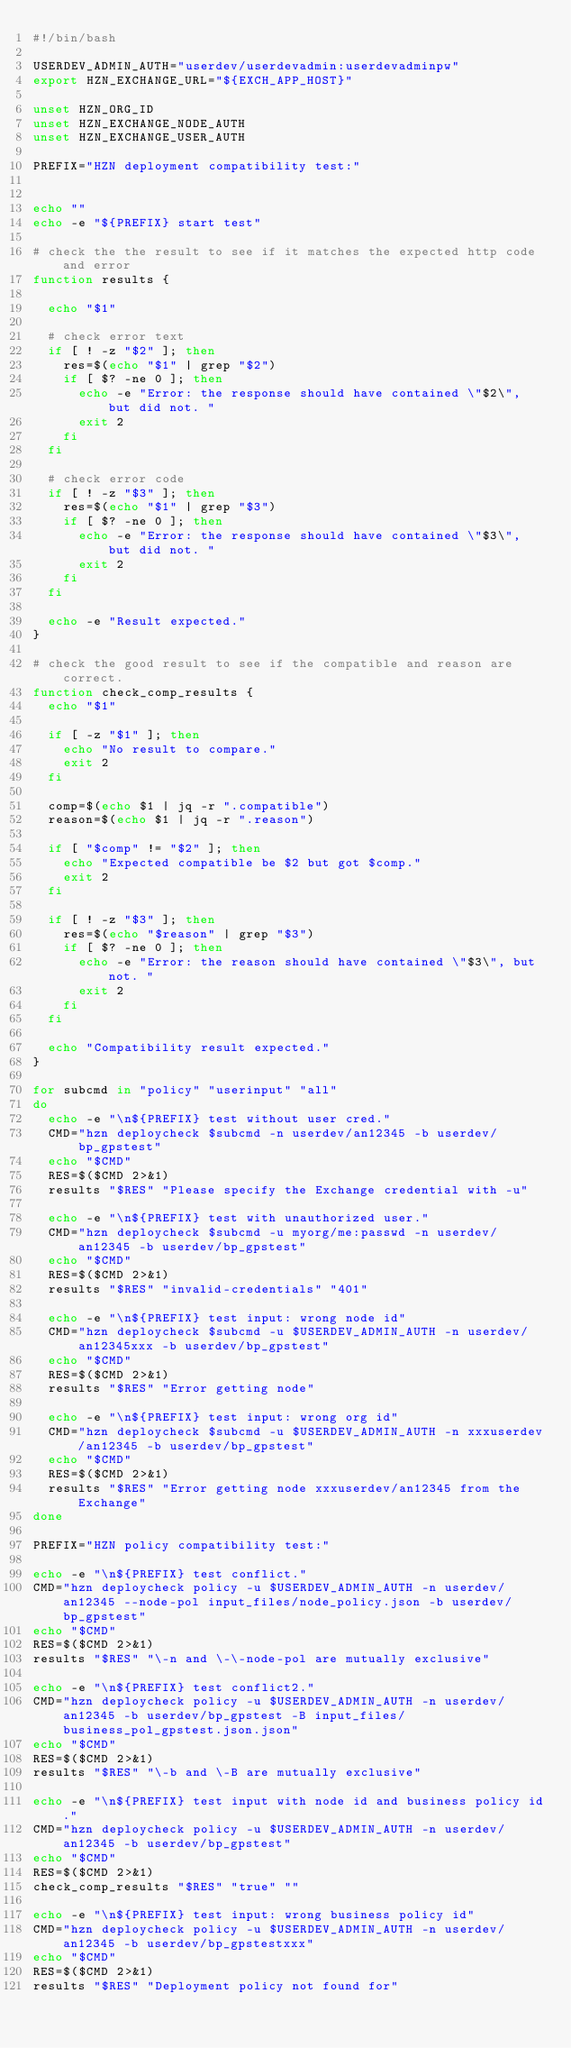Convert code to text. <code><loc_0><loc_0><loc_500><loc_500><_Bash_>#!/bin/bash

USERDEV_ADMIN_AUTH="userdev/userdevadmin:userdevadminpw"
export HZN_EXCHANGE_URL="${EXCH_APP_HOST}"

unset HZN_ORG_ID
unset HZN_EXCHANGE_NODE_AUTH
unset HZN_EXCHANGE_USER_AUTH

PREFIX="HZN deployment compatibility test:"


echo ""
echo -e "${PREFIX} start test"

# check the the result to see if it matches the expected http code and error
function results {

  echo "$1"

  # check error text
  if [ ! -z "$2" ]; then
    res=$(echo "$1" | grep "$2")
    if [ $? -ne 0 ]; then
      echo -e "Error: the response should have contained \"$2\", but did not. "
      exit 2
    fi
  fi

  # check error code
  if [ ! -z "$3" ]; then
    res=$(echo "$1" | grep "$3")
    if [ $? -ne 0 ]; then
      echo -e "Error: the response should have contained \"$3\", but did not. "
      exit 2
    fi
  fi

  echo -e "Result expected."
}

# check the good result to see if the compatible and reason are correct.
function check_comp_results {
  echo "$1"

  if [ -z "$1" ]; then
    echo "No result to compare."
    exit 2
  fi

  comp=$(echo $1 | jq -r ".compatible")
  reason=$(echo $1 | jq -r ".reason")

  if [ "$comp" != "$2" ]; then
    echo "Expected compatible be $2 but got $comp."
    exit 2
  fi

  if [ ! -z "$3" ]; then
    res=$(echo "$reason" | grep "$3")
    if [ $? -ne 0 ]; then
      echo -e "Error: the reason should have contained \"$3\", but not. "
      exit 2
    fi
  fi

  echo "Compatibility result expected."
}

for subcmd in "policy" "userinput" "all"
do
  echo -e "\n${PREFIX} test without user cred."
  CMD="hzn deploycheck $subcmd -n userdev/an12345 -b userdev/bp_gpstest"
  echo "$CMD"
  RES=$($CMD 2>&1)
  results "$RES" "Please specify the Exchange credential with -u"

  echo -e "\n${PREFIX} test with unauthorized user."
  CMD="hzn deploycheck $subcmd -u myorg/me:passwd -n userdev/an12345 -b userdev/bp_gpstest"
  echo "$CMD"
  RES=$($CMD 2>&1)
  results "$RES" "invalid-credentials" "401"

  echo -e "\n${PREFIX} test input: wrong node id"
  CMD="hzn deploycheck $subcmd -u $USERDEV_ADMIN_AUTH -n userdev/an12345xxx -b userdev/bp_gpstest"
  echo "$CMD"
  RES=$($CMD 2>&1)
  results "$RES" "Error getting node"

  echo -e "\n${PREFIX} test input: wrong org id"
  CMD="hzn deploycheck $subcmd -u $USERDEV_ADMIN_AUTH -n xxxuserdev/an12345 -b userdev/bp_gpstest"
  echo "$CMD"
  RES=$($CMD 2>&1)
  results "$RES" "Error getting node xxxuserdev/an12345 from the Exchange"
done

PREFIX="HZN policy compatibility test:"

echo -e "\n${PREFIX} test conflict."
CMD="hzn deploycheck policy -u $USERDEV_ADMIN_AUTH -n userdev/an12345 --node-pol input_files/node_policy.json -b userdev/bp_gpstest"
echo "$CMD"
RES=$($CMD 2>&1)
results "$RES" "\-n and \-\-node-pol are mutually exclusive"

echo -e "\n${PREFIX} test conflict2."
CMD="hzn deploycheck policy -u $USERDEV_ADMIN_AUTH -n userdev/an12345 -b userdev/bp_gpstest -B input_files/business_pol_gpstest.json.json"
echo "$CMD"
RES=$($CMD 2>&1)
results "$RES" "\-b and \-B are mutually exclusive"

echo -e "\n${PREFIX} test input with node id and business policy id."
CMD="hzn deploycheck policy -u $USERDEV_ADMIN_AUTH -n userdev/an12345 -b userdev/bp_gpstest"
echo "$CMD"
RES=$($CMD 2>&1)
check_comp_results "$RES" "true" ""

echo -e "\n${PREFIX} test input: wrong business policy id"
CMD="hzn deploycheck policy -u $USERDEV_ADMIN_AUTH -n userdev/an12345 -b userdev/bp_gpstestxxx"
echo "$CMD"
RES=$($CMD 2>&1)
results "$RES" "Deployment policy not found for"
</code> 